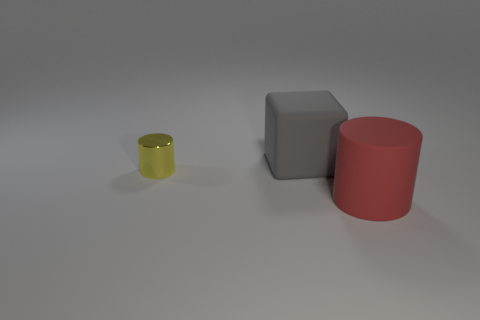Are there any other things that have the same size as the metal cylinder?
Ensure brevity in your answer.  No. There is a large red object that is the same shape as the tiny yellow thing; what is it made of?
Make the answer very short. Rubber. The big object that is behind the big rubber thing that is right of the matte object on the left side of the large red rubber cylinder is what color?
Provide a short and direct response. Gray. How many objects are both in front of the big rubber cube and on the left side of the large cylinder?
Provide a short and direct response. 1. What number of spheres are gray rubber objects or red objects?
Keep it short and to the point. 0. Are there any gray things?
Keep it short and to the point. Yes. What number of other objects are there of the same material as the tiny yellow thing?
Provide a succinct answer. 0. What is the material of the red cylinder that is the same size as the gray rubber object?
Make the answer very short. Rubber. Do the rubber object on the right side of the large gray thing and the tiny yellow thing have the same shape?
Provide a succinct answer. Yes. What number of things are big things that are on the left side of the big red cylinder or big purple metallic cylinders?
Provide a short and direct response. 1. 